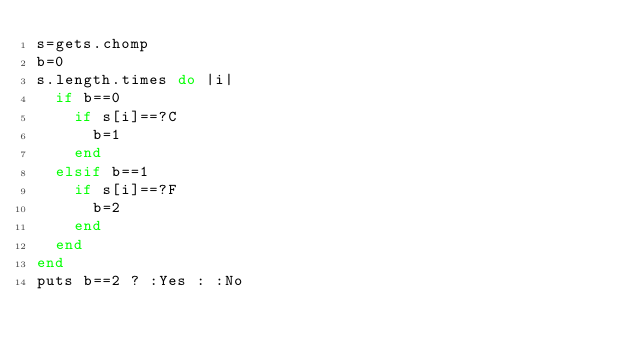Convert code to text. <code><loc_0><loc_0><loc_500><loc_500><_Ruby_>s=gets.chomp
b=0
s.length.times do |i|
  if b==0
    if s[i]==?C
      b=1
    end
  elsif b==1
    if s[i]==?F
      b=2
    end
  end
end
puts b==2 ? :Yes : :No</code> 